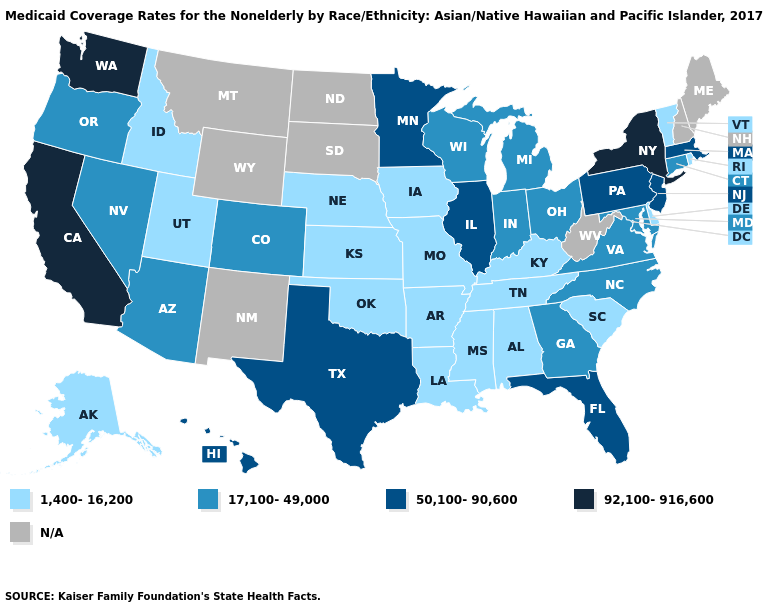Name the states that have a value in the range N/A?
Concise answer only. Maine, Montana, New Hampshire, New Mexico, North Dakota, South Dakota, West Virginia, Wyoming. What is the highest value in states that border Michigan?
Keep it brief. 17,100-49,000. Name the states that have a value in the range 1,400-16,200?
Quick response, please. Alabama, Alaska, Arkansas, Delaware, Idaho, Iowa, Kansas, Kentucky, Louisiana, Mississippi, Missouri, Nebraska, Oklahoma, Rhode Island, South Carolina, Tennessee, Utah, Vermont. Which states hav the highest value in the Northeast?
Keep it brief. New York. What is the value of Virginia?
Quick response, please. 17,100-49,000. What is the value of Delaware?
Keep it brief. 1,400-16,200. Among the states that border Minnesota , does Wisconsin have the lowest value?
Concise answer only. No. Does Massachusetts have the highest value in the Northeast?
Give a very brief answer. No. What is the highest value in the USA?
Be succinct. 92,100-916,600. Name the states that have a value in the range 17,100-49,000?
Short answer required. Arizona, Colorado, Connecticut, Georgia, Indiana, Maryland, Michigan, Nevada, North Carolina, Ohio, Oregon, Virginia, Wisconsin. Name the states that have a value in the range 50,100-90,600?
Concise answer only. Florida, Hawaii, Illinois, Massachusetts, Minnesota, New Jersey, Pennsylvania, Texas. What is the value of North Carolina?
Give a very brief answer. 17,100-49,000. 